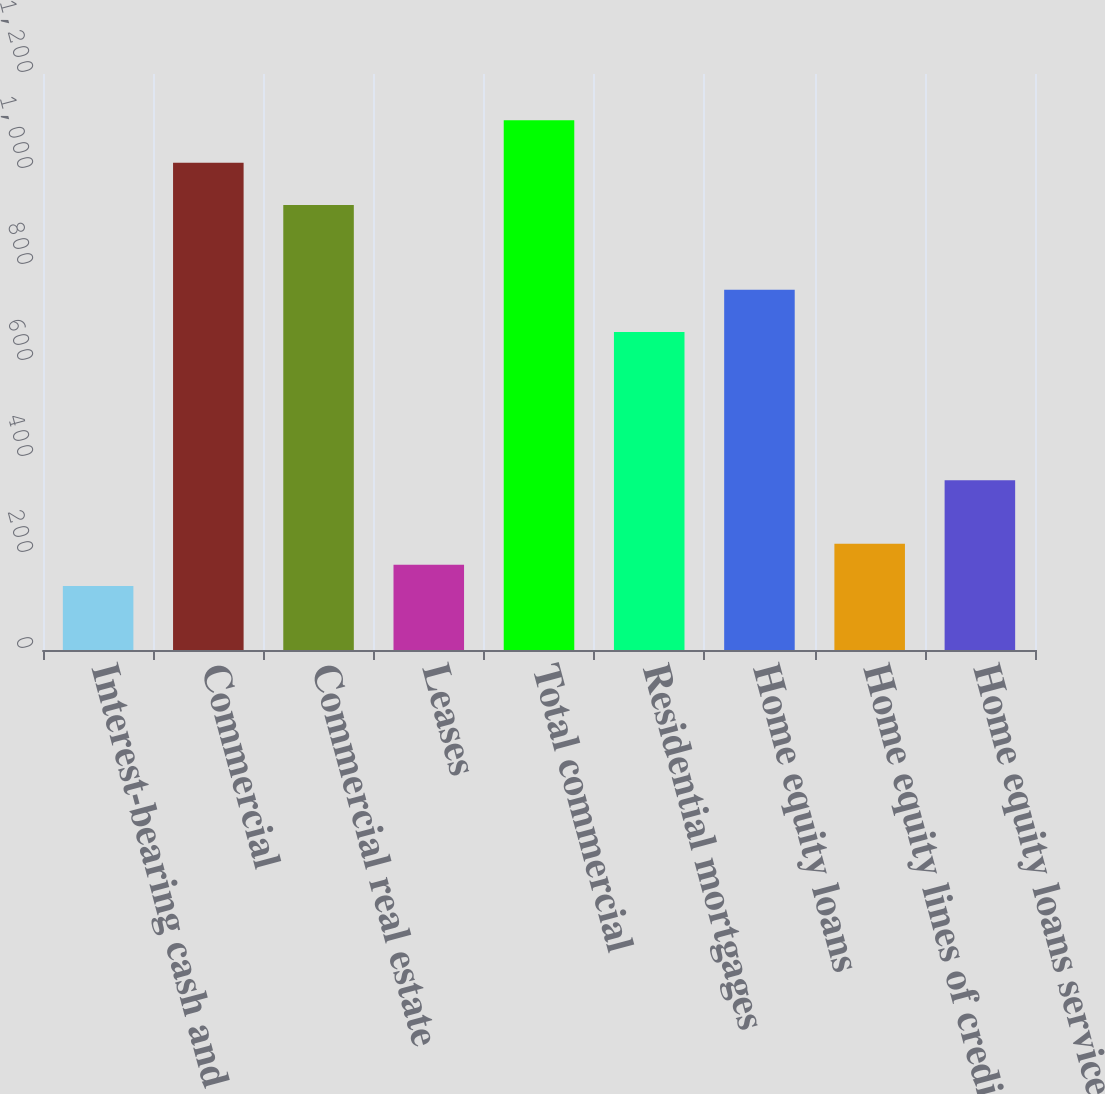<chart> <loc_0><loc_0><loc_500><loc_500><bar_chart><fcel>Interest-bearing cash and due<fcel>Commercial<fcel>Commercial real estate<fcel>Leases<fcel>Total commercial<fcel>Residential mortgages<fcel>Home equity loans<fcel>Home equity lines of credit<fcel>Home equity loans serviced by<nl><fcel>133.3<fcel>1015.3<fcel>927.1<fcel>177.4<fcel>1103.5<fcel>662.5<fcel>750.7<fcel>221.5<fcel>353.8<nl></chart> 